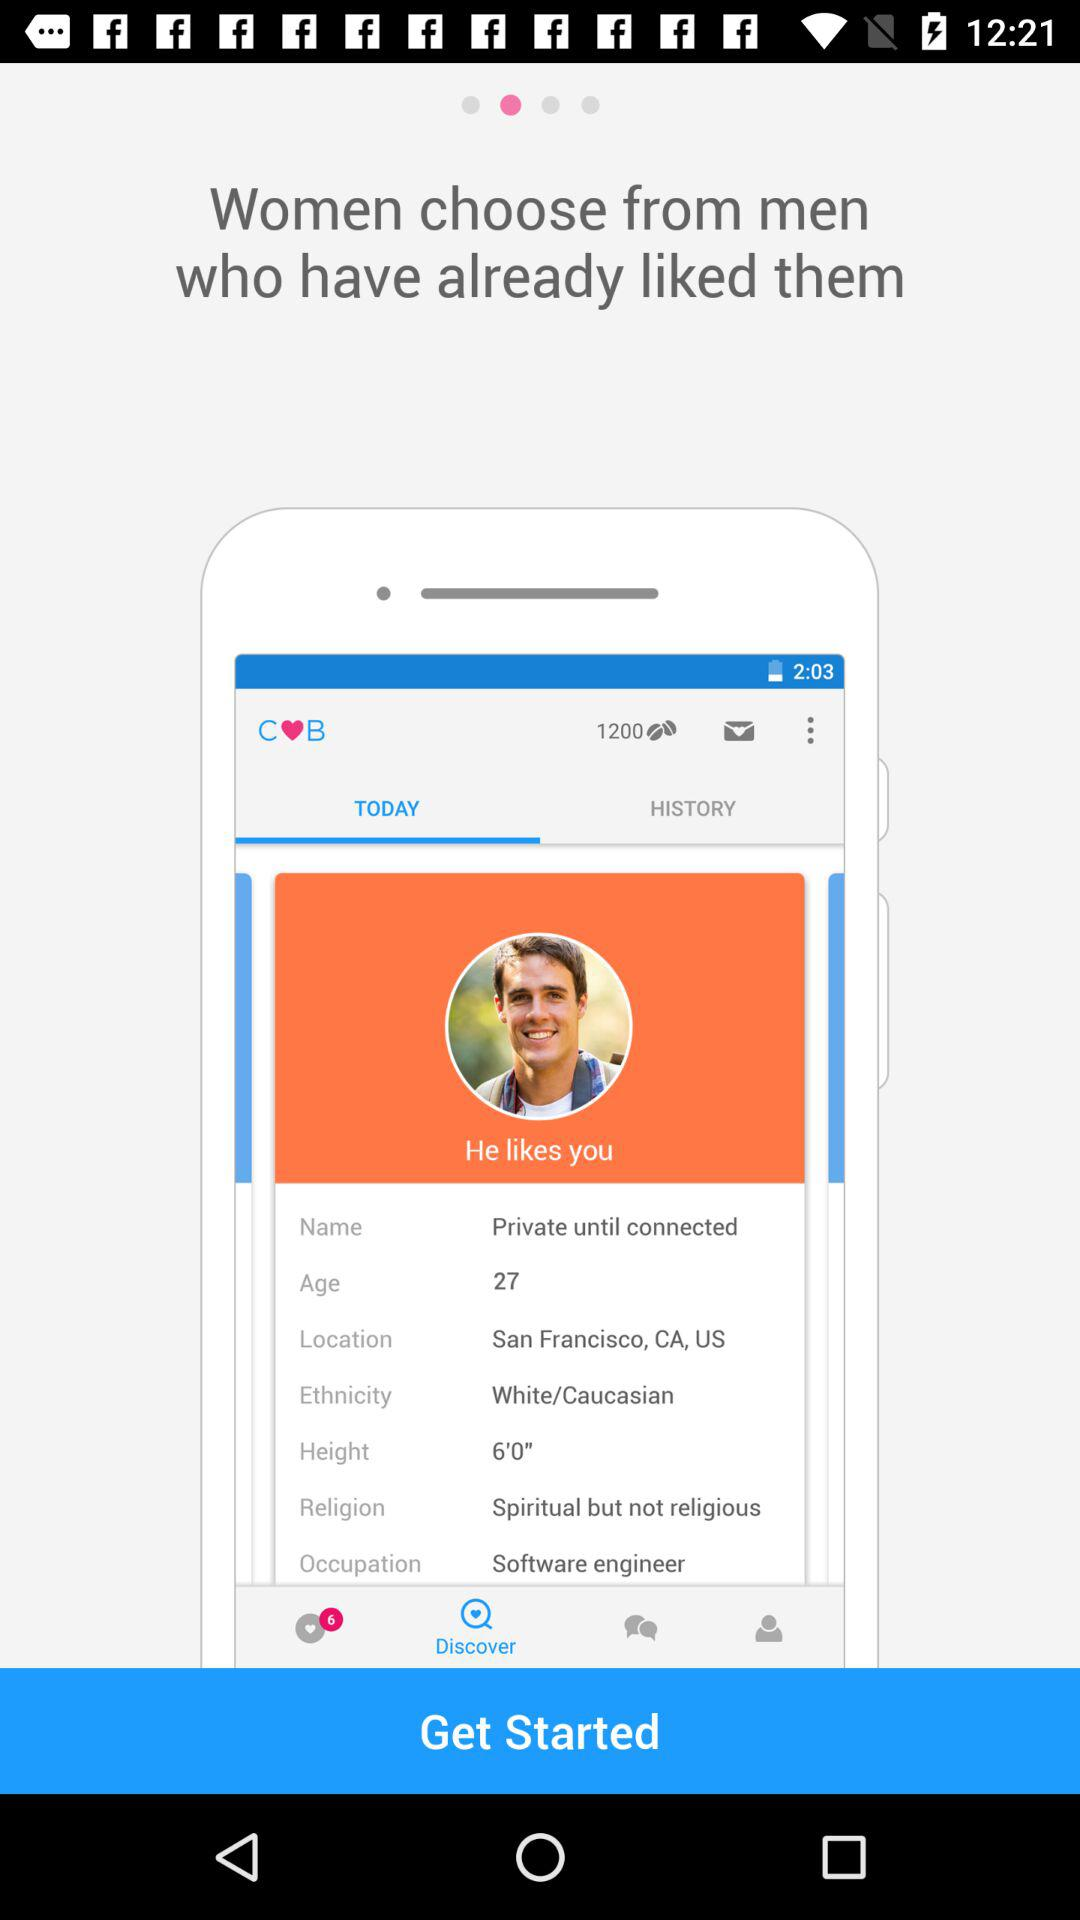Which tab is selected? The selected tab is "TODAY". 